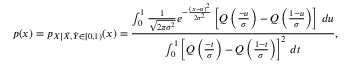<formula> <loc_0><loc_0><loc_500><loc_500>p ( x ) = p _ { X | \tilde { X } , \tilde { Y } \in [ 0 , 1 ) } ( x ) = \frac { \int _ { 0 } ^ { 1 } \frac { 1 } { \sqrt { 2 \pi \sigma ^ { 2 } } } e ^ { - \frac { ( x - u ) ^ { 2 } } { 2 \sigma ^ { 2 } } } \left [ Q \left ( \frac { - u } { \sigma } \right ) - Q \left ( \frac { 1 - u } { \sigma } \right ) \right ] \, d u } { \int _ { 0 } ^ { 1 } \left [ Q \left ( \frac { - t } { \sigma } \right ) - Q \left ( \frac { 1 - t } { \sigma } \right ) \right ] ^ { 2 } \, d t } ,</formula> 